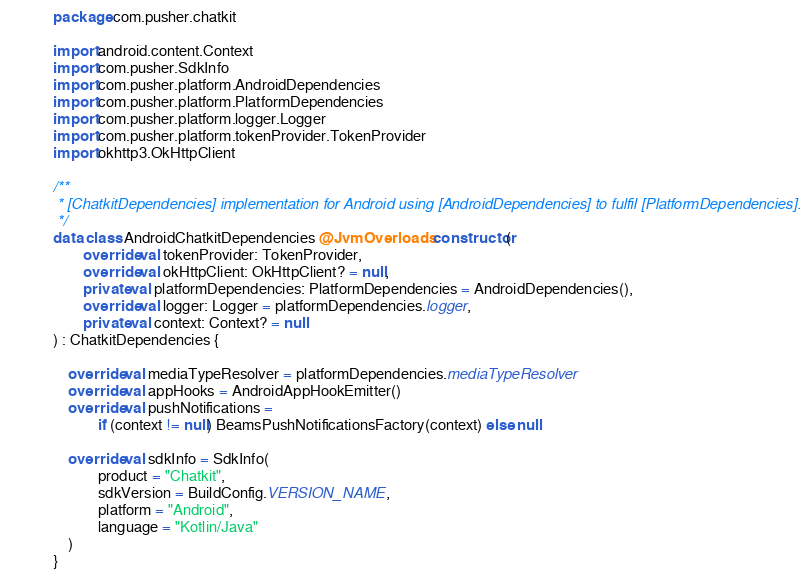<code> <loc_0><loc_0><loc_500><loc_500><_Kotlin_>package com.pusher.chatkit

import android.content.Context
import com.pusher.SdkInfo
import com.pusher.platform.AndroidDependencies
import com.pusher.platform.PlatformDependencies
import com.pusher.platform.logger.Logger
import com.pusher.platform.tokenProvider.TokenProvider
import okhttp3.OkHttpClient

/**
 * [ChatkitDependencies] implementation for Android using [AndroidDependencies] to fulfil [PlatformDependencies].
 */
data class AndroidChatkitDependencies @JvmOverloads constructor(
        override val tokenProvider: TokenProvider,
        override val okHttpClient: OkHttpClient? = null,
        private val platformDependencies: PlatformDependencies = AndroidDependencies(),
        override val logger: Logger = platformDependencies.logger,
        private val context: Context? = null
) : ChatkitDependencies {

    override val mediaTypeResolver = platformDependencies.mediaTypeResolver
    override val appHooks = AndroidAppHookEmitter()
    override val pushNotifications =
            if (context != null) BeamsPushNotificationsFactory(context) else null

    override val sdkInfo = SdkInfo(
            product = "Chatkit",
            sdkVersion = BuildConfig.VERSION_NAME,
            platform = "Android",
            language = "Kotlin/Java"
    )
}
</code> 